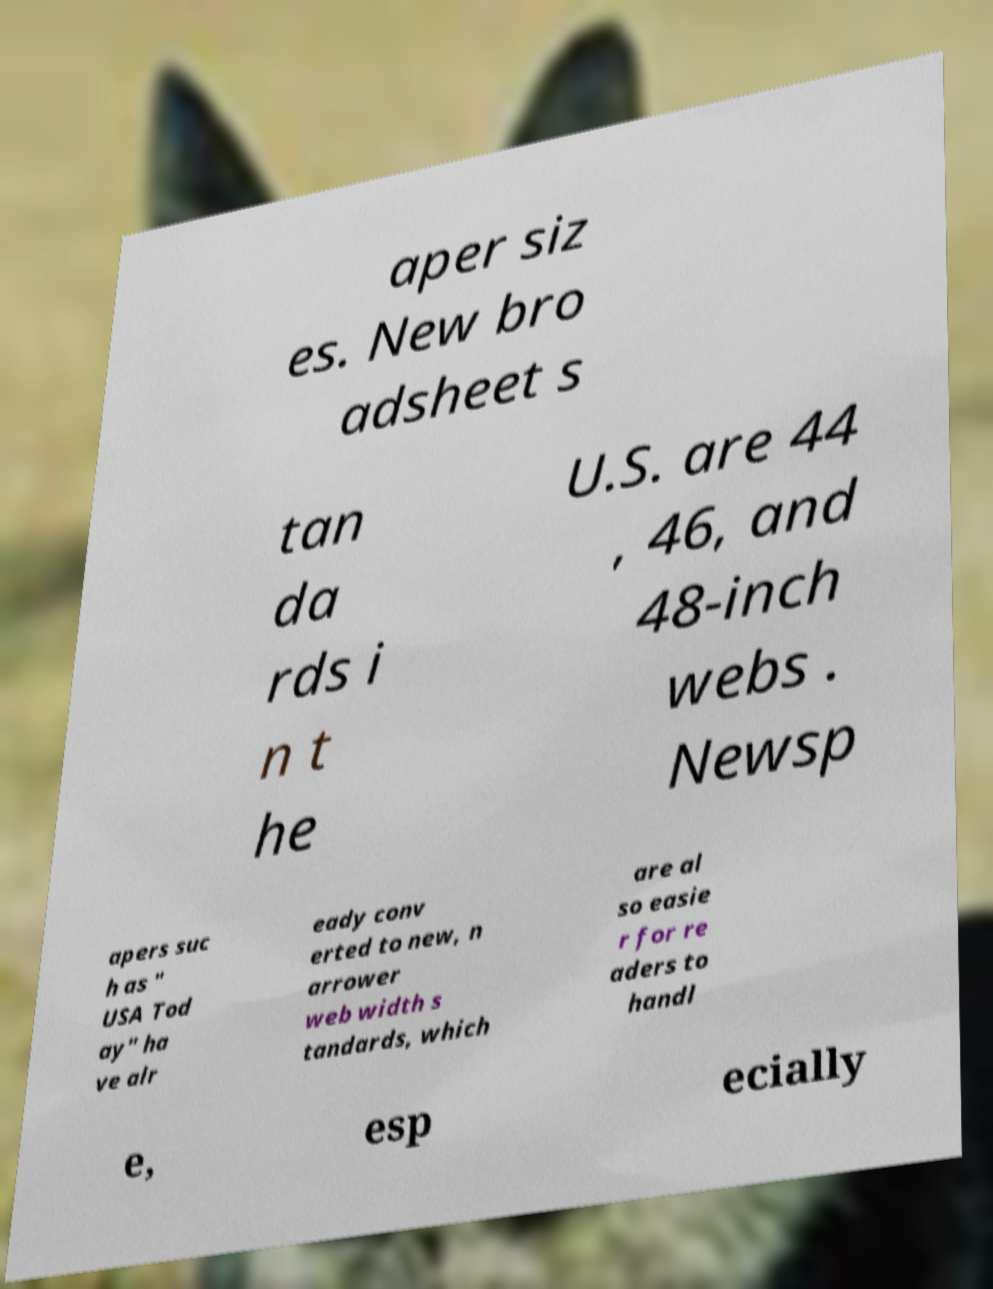For documentation purposes, I need the text within this image transcribed. Could you provide that? aper siz es. New bro adsheet s tan da rds i n t he U.S. are 44 , 46, and 48-inch webs . Newsp apers suc h as " USA Tod ay" ha ve alr eady conv erted to new, n arrower web width s tandards, which are al so easie r for re aders to handl e, esp ecially 